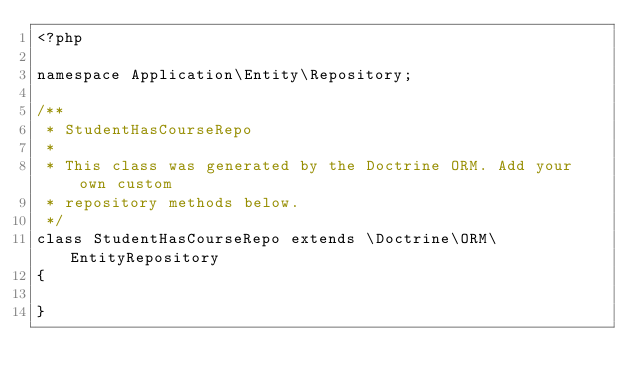Convert code to text. <code><loc_0><loc_0><loc_500><loc_500><_PHP_><?php

namespace Application\Entity\Repository;

/**
 * StudentHasCourseRepo
 *
 * This class was generated by the Doctrine ORM. Add your own custom
 * repository methods below.
 */
class StudentHasCourseRepo extends \Doctrine\ORM\EntityRepository
{
 	
}
</code> 